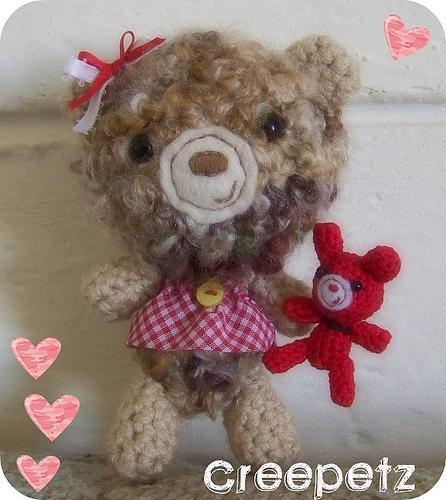How many teddy bears are there?
Give a very brief answer. 2. 